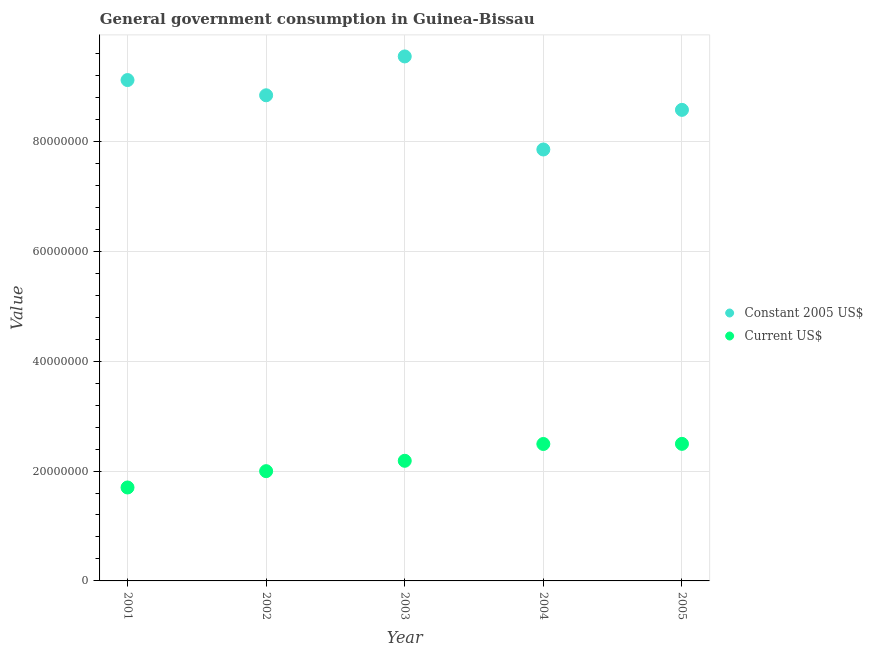How many different coloured dotlines are there?
Keep it short and to the point. 2. Is the number of dotlines equal to the number of legend labels?
Provide a short and direct response. Yes. What is the value consumed in constant 2005 us$ in 2005?
Provide a succinct answer. 8.57e+07. Across all years, what is the maximum value consumed in constant 2005 us$?
Offer a terse response. 9.55e+07. Across all years, what is the minimum value consumed in constant 2005 us$?
Your answer should be very brief. 7.85e+07. In which year was the value consumed in current us$ minimum?
Your response must be concise. 2001. What is the total value consumed in constant 2005 us$ in the graph?
Your answer should be very brief. 4.39e+08. What is the difference between the value consumed in current us$ in 2001 and that in 2004?
Provide a short and direct response. -7.92e+06. What is the difference between the value consumed in current us$ in 2001 and the value consumed in constant 2005 us$ in 2004?
Your response must be concise. -6.15e+07. What is the average value consumed in constant 2005 us$ per year?
Your response must be concise. 8.79e+07. In the year 2004, what is the difference between the value consumed in current us$ and value consumed in constant 2005 us$?
Offer a terse response. -5.36e+07. What is the ratio of the value consumed in current us$ in 2004 to that in 2005?
Keep it short and to the point. 1. Is the value consumed in current us$ in 2003 less than that in 2005?
Your response must be concise. Yes. Is the difference between the value consumed in current us$ in 2001 and 2005 greater than the difference between the value consumed in constant 2005 us$ in 2001 and 2005?
Provide a short and direct response. No. What is the difference between the highest and the second highest value consumed in current us$?
Your answer should be compact. 2.39e+04. What is the difference between the highest and the lowest value consumed in constant 2005 us$?
Provide a short and direct response. 1.69e+07. In how many years, is the value consumed in current us$ greater than the average value consumed in current us$ taken over all years?
Your answer should be very brief. 3. Does the value consumed in constant 2005 us$ monotonically increase over the years?
Make the answer very short. No. What is the difference between two consecutive major ticks on the Y-axis?
Give a very brief answer. 2.00e+07. Are the values on the major ticks of Y-axis written in scientific E-notation?
Offer a very short reply. No. Does the graph contain any zero values?
Provide a short and direct response. No. What is the title of the graph?
Give a very brief answer. General government consumption in Guinea-Bissau. What is the label or title of the Y-axis?
Provide a succinct answer. Value. What is the Value of Constant 2005 US$ in 2001?
Ensure brevity in your answer.  9.12e+07. What is the Value of Current US$ in 2001?
Provide a succinct answer. 1.70e+07. What is the Value in Constant 2005 US$ in 2002?
Make the answer very short. 8.84e+07. What is the Value of Current US$ in 2002?
Your response must be concise. 2.00e+07. What is the Value of Constant 2005 US$ in 2003?
Provide a succinct answer. 9.55e+07. What is the Value in Current US$ in 2003?
Keep it short and to the point. 2.19e+07. What is the Value of Constant 2005 US$ in 2004?
Offer a terse response. 7.85e+07. What is the Value of Current US$ in 2004?
Give a very brief answer. 2.49e+07. What is the Value of Constant 2005 US$ in 2005?
Offer a terse response. 8.57e+07. What is the Value in Current US$ in 2005?
Your answer should be compact. 2.50e+07. Across all years, what is the maximum Value in Constant 2005 US$?
Your answer should be compact. 9.55e+07. Across all years, what is the maximum Value in Current US$?
Offer a terse response. 2.50e+07. Across all years, what is the minimum Value in Constant 2005 US$?
Your response must be concise. 7.85e+07. Across all years, what is the minimum Value of Current US$?
Offer a very short reply. 1.70e+07. What is the total Value of Constant 2005 US$ in the graph?
Offer a terse response. 4.39e+08. What is the total Value of Current US$ in the graph?
Provide a succinct answer. 1.09e+08. What is the difference between the Value in Constant 2005 US$ in 2001 and that in 2002?
Provide a short and direct response. 2.77e+06. What is the difference between the Value in Current US$ in 2001 and that in 2002?
Make the answer very short. -2.97e+06. What is the difference between the Value of Constant 2005 US$ in 2001 and that in 2003?
Your answer should be compact. -4.30e+06. What is the difference between the Value of Current US$ in 2001 and that in 2003?
Give a very brief answer. -4.86e+06. What is the difference between the Value in Constant 2005 US$ in 2001 and that in 2004?
Your response must be concise. 1.26e+07. What is the difference between the Value in Current US$ in 2001 and that in 2004?
Keep it short and to the point. -7.92e+06. What is the difference between the Value of Constant 2005 US$ in 2001 and that in 2005?
Provide a short and direct response. 5.43e+06. What is the difference between the Value of Current US$ in 2001 and that in 2005?
Ensure brevity in your answer.  -7.94e+06. What is the difference between the Value in Constant 2005 US$ in 2002 and that in 2003?
Provide a short and direct response. -7.07e+06. What is the difference between the Value in Current US$ in 2002 and that in 2003?
Offer a terse response. -1.89e+06. What is the difference between the Value in Constant 2005 US$ in 2002 and that in 2004?
Offer a very short reply. 9.87e+06. What is the difference between the Value of Current US$ in 2002 and that in 2004?
Your answer should be compact. -4.95e+06. What is the difference between the Value of Constant 2005 US$ in 2002 and that in 2005?
Your answer should be very brief. 2.65e+06. What is the difference between the Value in Current US$ in 2002 and that in 2005?
Provide a short and direct response. -4.97e+06. What is the difference between the Value in Constant 2005 US$ in 2003 and that in 2004?
Make the answer very short. 1.69e+07. What is the difference between the Value in Current US$ in 2003 and that in 2004?
Ensure brevity in your answer.  -3.06e+06. What is the difference between the Value in Constant 2005 US$ in 2003 and that in 2005?
Provide a short and direct response. 9.73e+06. What is the difference between the Value in Current US$ in 2003 and that in 2005?
Your answer should be compact. -3.08e+06. What is the difference between the Value in Constant 2005 US$ in 2004 and that in 2005?
Make the answer very short. -7.21e+06. What is the difference between the Value in Current US$ in 2004 and that in 2005?
Your answer should be very brief. -2.39e+04. What is the difference between the Value in Constant 2005 US$ in 2001 and the Value in Current US$ in 2002?
Offer a very short reply. 7.12e+07. What is the difference between the Value in Constant 2005 US$ in 2001 and the Value in Current US$ in 2003?
Offer a terse response. 6.93e+07. What is the difference between the Value of Constant 2005 US$ in 2001 and the Value of Current US$ in 2004?
Give a very brief answer. 6.62e+07. What is the difference between the Value in Constant 2005 US$ in 2001 and the Value in Current US$ in 2005?
Offer a terse response. 6.62e+07. What is the difference between the Value of Constant 2005 US$ in 2002 and the Value of Current US$ in 2003?
Provide a succinct answer. 6.65e+07. What is the difference between the Value of Constant 2005 US$ in 2002 and the Value of Current US$ in 2004?
Your answer should be compact. 6.35e+07. What is the difference between the Value in Constant 2005 US$ in 2002 and the Value in Current US$ in 2005?
Your response must be concise. 6.35e+07. What is the difference between the Value of Constant 2005 US$ in 2003 and the Value of Current US$ in 2004?
Offer a very short reply. 7.05e+07. What is the difference between the Value of Constant 2005 US$ in 2003 and the Value of Current US$ in 2005?
Offer a very short reply. 7.05e+07. What is the difference between the Value in Constant 2005 US$ in 2004 and the Value in Current US$ in 2005?
Your answer should be compact. 5.36e+07. What is the average Value in Constant 2005 US$ per year?
Give a very brief answer. 8.79e+07. What is the average Value of Current US$ per year?
Provide a short and direct response. 2.17e+07. In the year 2001, what is the difference between the Value in Constant 2005 US$ and Value in Current US$?
Your answer should be very brief. 7.42e+07. In the year 2002, what is the difference between the Value of Constant 2005 US$ and Value of Current US$?
Your response must be concise. 6.84e+07. In the year 2003, what is the difference between the Value in Constant 2005 US$ and Value in Current US$?
Your answer should be very brief. 7.36e+07. In the year 2004, what is the difference between the Value of Constant 2005 US$ and Value of Current US$?
Provide a succinct answer. 5.36e+07. In the year 2005, what is the difference between the Value of Constant 2005 US$ and Value of Current US$?
Make the answer very short. 6.08e+07. What is the ratio of the Value of Constant 2005 US$ in 2001 to that in 2002?
Offer a very short reply. 1.03. What is the ratio of the Value in Current US$ in 2001 to that in 2002?
Ensure brevity in your answer.  0.85. What is the ratio of the Value in Constant 2005 US$ in 2001 to that in 2003?
Provide a short and direct response. 0.95. What is the ratio of the Value of Current US$ in 2001 to that in 2003?
Your answer should be compact. 0.78. What is the ratio of the Value in Constant 2005 US$ in 2001 to that in 2004?
Your answer should be compact. 1.16. What is the ratio of the Value of Current US$ in 2001 to that in 2004?
Offer a terse response. 0.68. What is the ratio of the Value of Constant 2005 US$ in 2001 to that in 2005?
Ensure brevity in your answer.  1.06. What is the ratio of the Value in Current US$ in 2001 to that in 2005?
Make the answer very short. 0.68. What is the ratio of the Value of Constant 2005 US$ in 2002 to that in 2003?
Offer a terse response. 0.93. What is the ratio of the Value of Current US$ in 2002 to that in 2003?
Offer a terse response. 0.91. What is the ratio of the Value of Constant 2005 US$ in 2002 to that in 2004?
Your answer should be compact. 1.13. What is the ratio of the Value in Current US$ in 2002 to that in 2004?
Offer a terse response. 0.8. What is the ratio of the Value in Constant 2005 US$ in 2002 to that in 2005?
Keep it short and to the point. 1.03. What is the ratio of the Value of Current US$ in 2002 to that in 2005?
Provide a short and direct response. 0.8. What is the ratio of the Value in Constant 2005 US$ in 2003 to that in 2004?
Your answer should be compact. 1.22. What is the ratio of the Value of Current US$ in 2003 to that in 2004?
Keep it short and to the point. 0.88. What is the ratio of the Value in Constant 2005 US$ in 2003 to that in 2005?
Ensure brevity in your answer.  1.11. What is the ratio of the Value in Current US$ in 2003 to that in 2005?
Keep it short and to the point. 0.88. What is the ratio of the Value of Constant 2005 US$ in 2004 to that in 2005?
Offer a terse response. 0.92. What is the difference between the highest and the second highest Value of Constant 2005 US$?
Your response must be concise. 4.30e+06. What is the difference between the highest and the second highest Value in Current US$?
Your response must be concise. 2.39e+04. What is the difference between the highest and the lowest Value in Constant 2005 US$?
Give a very brief answer. 1.69e+07. What is the difference between the highest and the lowest Value in Current US$?
Provide a succinct answer. 7.94e+06. 